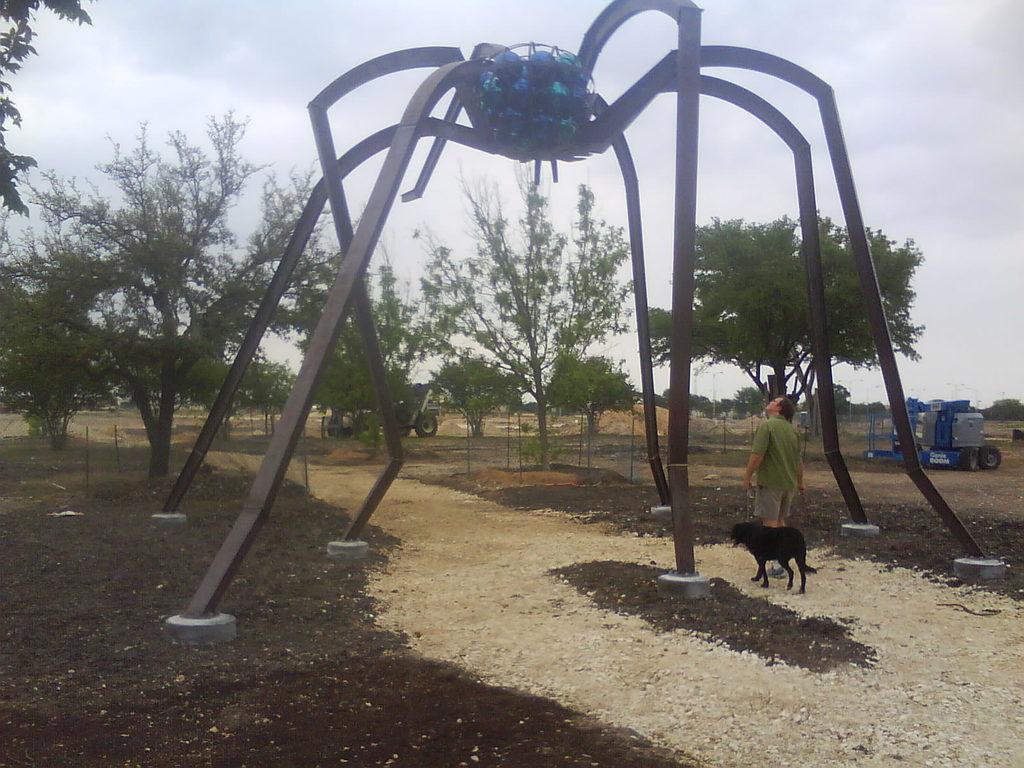Can you describe this image briefly? In this picture we can see the spider structure which is made from the steel. Here we can see a man who is wearing t-shirt, short and shoe. He is standing near to the black dog. On the right we can see vehicle in the farm land. Here we can see another vehicle which is parked near to the fencing. In the background we can see many trees. At top we can see sky and clouds. 